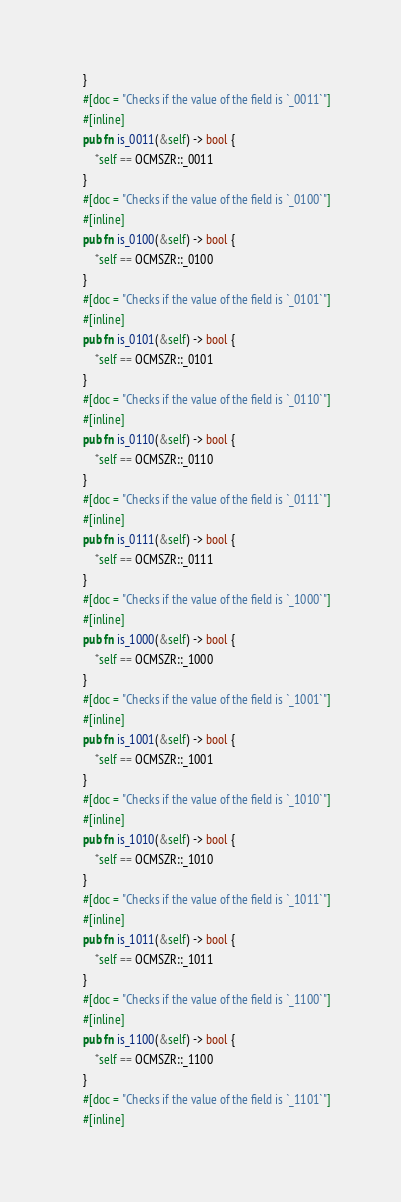<code> <loc_0><loc_0><loc_500><loc_500><_Rust_>    }
    #[doc = "Checks if the value of the field is `_0011`"]
    #[inline]
    pub fn is_0011(&self) -> bool {
        *self == OCMSZR::_0011
    }
    #[doc = "Checks if the value of the field is `_0100`"]
    #[inline]
    pub fn is_0100(&self) -> bool {
        *self == OCMSZR::_0100
    }
    #[doc = "Checks if the value of the field is `_0101`"]
    #[inline]
    pub fn is_0101(&self) -> bool {
        *self == OCMSZR::_0101
    }
    #[doc = "Checks if the value of the field is `_0110`"]
    #[inline]
    pub fn is_0110(&self) -> bool {
        *self == OCMSZR::_0110
    }
    #[doc = "Checks if the value of the field is `_0111`"]
    #[inline]
    pub fn is_0111(&self) -> bool {
        *self == OCMSZR::_0111
    }
    #[doc = "Checks if the value of the field is `_1000`"]
    #[inline]
    pub fn is_1000(&self) -> bool {
        *self == OCMSZR::_1000
    }
    #[doc = "Checks if the value of the field is `_1001`"]
    #[inline]
    pub fn is_1001(&self) -> bool {
        *self == OCMSZR::_1001
    }
    #[doc = "Checks if the value of the field is `_1010`"]
    #[inline]
    pub fn is_1010(&self) -> bool {
        *self == OCMSZR::_1010
    }
    #[doc = "Checks if the value of the field is `_1011`"]
    #[inline]
    pub fn is_1011(&self) -> bool {
        *self == OCMSZR::_1011
    }
    #[doc = "Checks if the value of the field is `_1100`"]
    #[inline]
    pub fn is_1100(&self) -> bool {
        *self == OCMSZR::_1100
    }
    #[doc = "Checks if the value of the field is `_1101`"]
    #[inline]</code> 